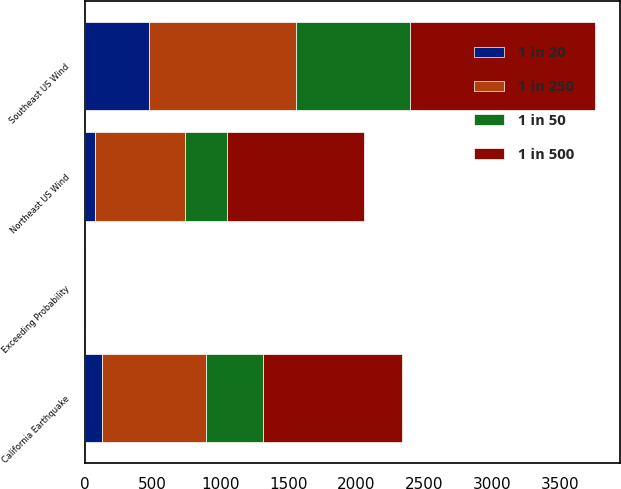Convert chart to OTSL. <chart><loc_0><loc_0><loc_500><loc_500><stacked_bar_chart><ecel><fcel>Exceeding Probability<fcel>Southeast US Wind<fcel>California Earthquake<fcel>Northeast US Wind<nl><fcel>1 in 20<fcel>5<fcel>472<fcel>127<fcel>76<nl><fcel>1 in 50<fcel>2<fcel>840<fcel>416<fcel>305<nl><fcel>1 in 250<fcel>1<fcel>1084<fcel>767<fcel>663<nl><fcel>1 in 500<fcel>0.4<fcel>1358<fcel>1028<fcel>1014<nl></chart> 